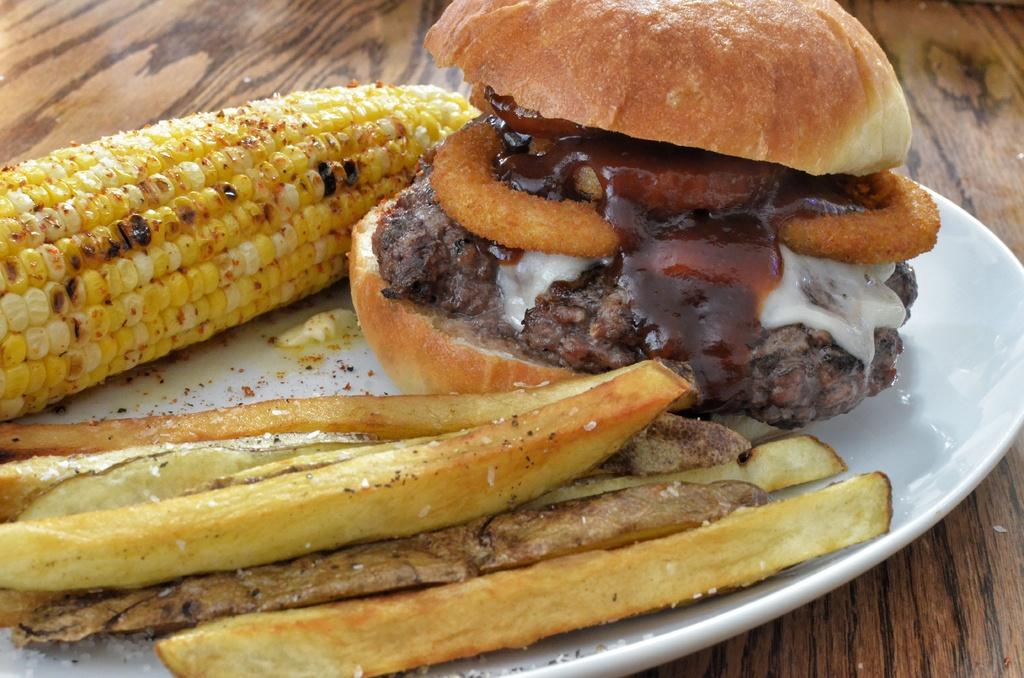What is on the plate in the image? There are food items on a plate in the image. What is the plate resting on? The plate is on a wooden surface. What type of toys can be seen on the plate in the image? There are no toys present on the plate in the image; it contains food items. 